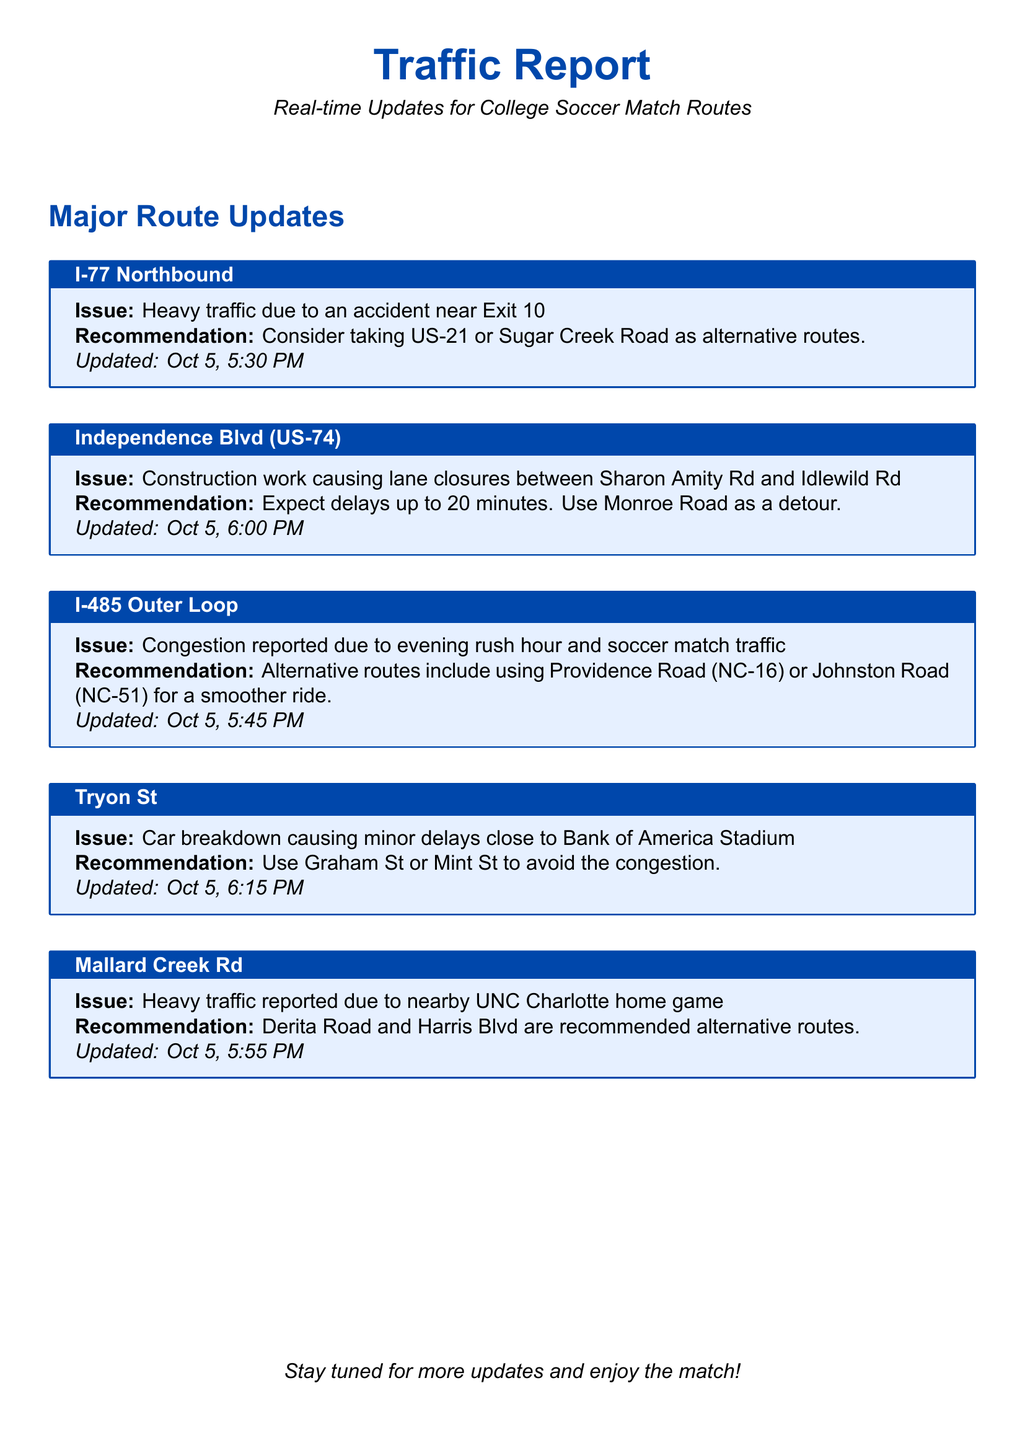What is the traffic issue reported on I-77 Northbound? The issue reported on I-77 Northbound is heavy traffic due to an accident near Exit 10.
Answer: Heavy traffic due to an accident near Exit 10 What alternative routes are recommended for I-485 Outer Loop? The recommended alternative routes for I-485 Outer Loop are Providence Road (NC-16) or Johnston Road (NC-51).
Answer: Providence Road (NC-16) or Johnston Road (NC-51) What time was the traffic update for Mallard Creek Rd issued? The traffic update for Mallard Creek Rd was issued at 5:55 PM on Oct 5.
Answer: 5:55 PM How long are the expected delays on Independence Blvd (US-74)? The expected delays on Independence Blvd (US-74) are up to 20 minutes.
Answer: Up to 20 minutes What should drivers use to avoid congestion near Bank of America Stadium? Drivers should use Graham St or Mint St to avoid congestion near Bank of America Stadium.
Answer: Graham St or Mint St Which road is causing minor delays on Tryon St? A car breakdown is causing minor delays on Tryon St.
Answer: A car breakdown What event is causing heavy traffic on Mallard Creek Rd? The heavy traffic on Mallard Creek Rd is due to a nearby UNC Charlotte home game.
Answer: A nearby UNC Charlotte home game What is indicated about I-485 traffic on the report? The report indicates congestion due to evening rush hour and soccer match traffic on I-485.
Answer: Congestion due to evening rush hour and soccer match traffic 